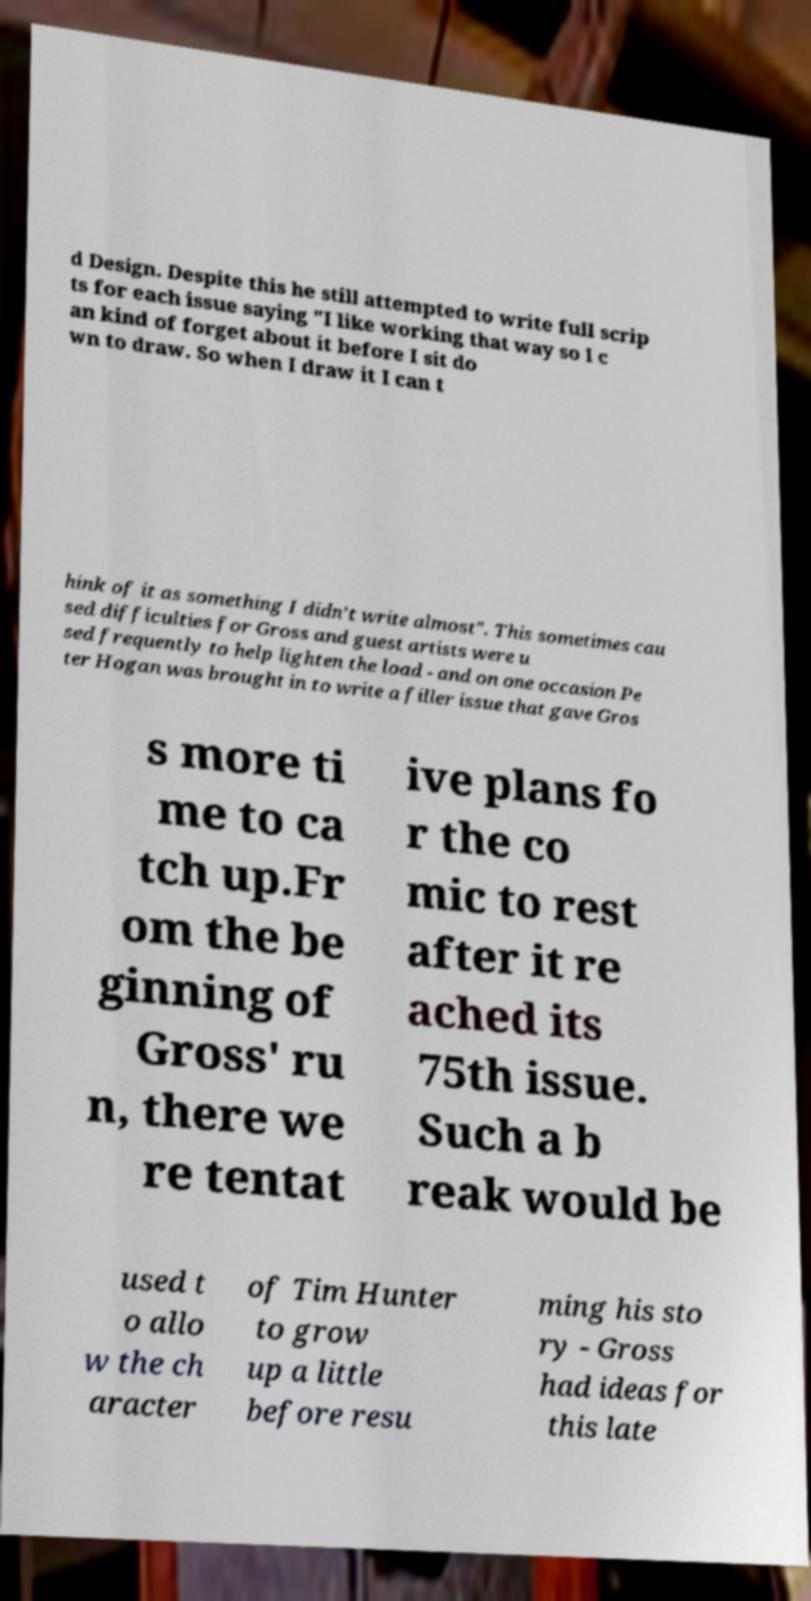For documentation purposes, I need the text within this image transcribed. Could you provide that? d Design. Despite this he still attempted to write full scrip ts for each issue saying "I like working that way so I c an kind of forget about it before I sit do wn to draw. So when I draw it I can t hink of it as something I didn’t write almost". This sometimes cau sed difficulties for Gross and guest artists were u sed frequently to help lighten the load - and on one occasion Pe ter Hogan was brought in to write a filler issue that gave Gros s more ti me to ca tch up.Fr om the be ginning of Gross' ru n, there we re tentat ive plans fo r the co mic to rest after it re ached its 75th issue. Such a b reak would be used t o allo w the ch aracter of Tim Hunter to grow up a little before resu ming his sto ry - Gross had ideas for this late 